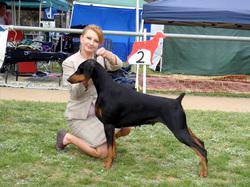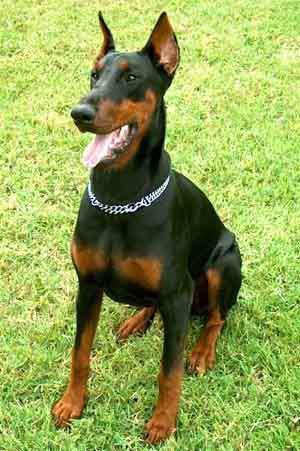The first image is the image on the left, the second image is the image on the right. Analyze the images presented: Is the assertion "there is a doberman wearing a silver chain collar" valid? Answer yes or no. Yes. The first image is the image on the left, the second image is the image on the right. For the images displayed, is the sentence "The left image contains a left-facing dock-tailed dog standing in profile, with a handler behind it, and the right image contains one erect-eared dog wearing a chain collar." factually correct? Answer yes or no. Yes. 